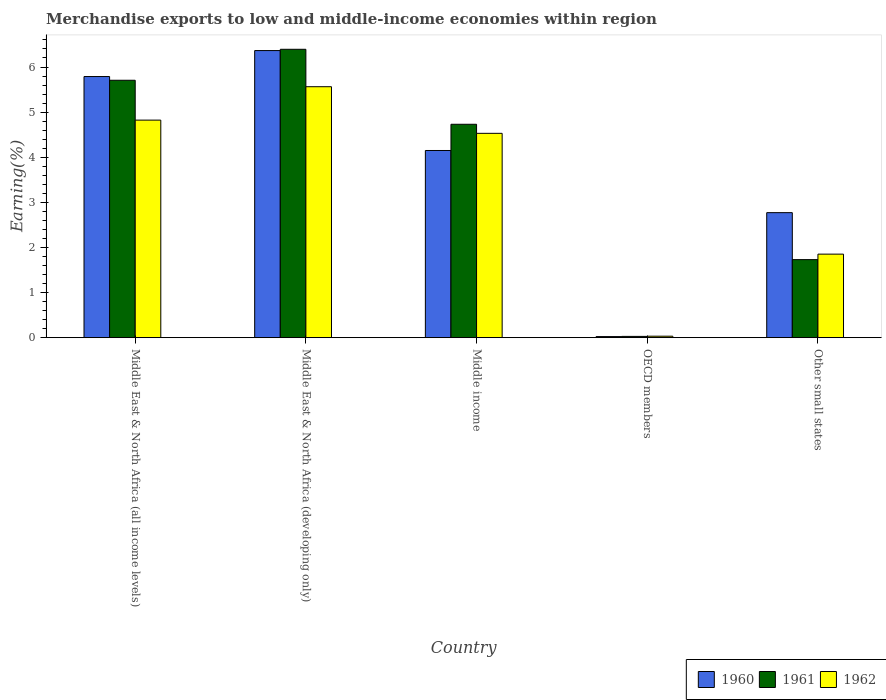Are the number of bars per tick equal to the number of legend labels?
Your answer should be compact. Yes. Are the number of bars on each tick of the X-axis equal?
Your response must be concise. Yes. How many bars are there on the 5th tick from the right?
Keep it short and to the point. 3. In how many cases, is the number of bars for a given country not equal to the number of legend labels?
Offer a terse response. 0. What is the percentage of amount earned from merchandise exports in 1962 in Other small states?
Provide a short and direct response. 1.85. Across all countries, what is the maximum percentage of amount earned from merchandise exports in 1961?
Provide a short and direct response. 6.39. Across all countries, what is the minimum percentage of amount earned from merchandise exports in 1962?
Provide a short and direct response. 0.03. In which country was the percentage of amount earned from merchandise exports in 1962 maximum?
Offer a terse response. Middle East & North Africa (developing only). What is the total percentage of amount earned from merchandise exports in 1961 in the graph?
Your response must be concise. 18.59. What is the difference between the percentage of amount earned from merchandise exports in 1961 in Middle East & North Africa (developing only) and that in Other small states?
Ensure brevity in your answer.  4.66. What is the difference between the percentage of amount earned from merchandise exports in 1961 in Middle income and the percentage of amount earned from merchandise exports in 1962 in Other small states?
Offer a very short reply. 2.88. What is the average percentage of amount earned from merchandise exports in 1962 per country?
Ensure brevity in your answer.  3.36. What is the difference between the percentage of amount earned from merchandise exports of/in 1961 and percentage of amount earned from merchandise exports of/in 1962 in Other small states?
Offer a terse response. -0.12. In how many countries, is the percentage of amount earned from merchandise exports in 1961 greater than 0.8 %?
Provide a short and direct response. 4. What is the ratio of the percentage of amount earned from merchandise exports in 1961 in Middle East & North Africa (all income levels) to that in Middle income?
Make the answer very short. 1.21. What is the difference between the highest and the second highest percentage of amount earned from merchandise exports in 1962?
Offer a very short reply. -0.29. What is the difference between the highest and the lowest percentage of amount earned from merchandise exports in 1962?
Provide a succinct answer. 5.53. In how many countries, is the percentage of amount earned from merchandise exports in 1960 greater than the average percentage of amount earned from merchandise exports in 1960 taken over all countries?
Give a very brief answer. 3. Is it the case that in every country, the sum of the percentage of amount earned from merchandise exports in 1961 and percentage of amount earned from merchandise exports in 1962 is greater than the percentage of amount earned from merchandise exports in 1960?
Offer a terse response. Yes. How many countries are there in the graph?
Ensure brevity in your answer.  5. What is the difference between two consecutive major ticks on the Y-axis?
Make the answer very short. 1. Are the values on the major ticks of Y-axis written in scientific E-notation?
Give a very brief answer. No. Does the graph contain grids?
Provide a succinct answer. No. How are the legend labels stacked?
Provide a succinct answer. Horizontal. What is the title of the graph?
Your answer should be compact. Merchandise exports to low and middle-income economies within region. Does "1960" appear as one of the legend labels in the graph?
Provide a succinct answer. Yes. What is the label or title of the Y-axis?
Offer a terse response. Earning(%). What is the Earning(%) in 1960 in Middle East & North Africa (all income levels)?
Provide a succinct answer. 5.79. What is the Earning(%) of 1961 in Middle East & North Africa (all income levels)?
Provide a succinct answer. 5.71. What is the Earning(%) of 1962 in Middle East & North Africa (all income levels)?
Your answer should be very brief. 4.82. What is the Earning(%) of 1960 in Middle East & North Africa (developing only)?
Your answer should be very brief. 6.36. What is the Earning(%) of 1961 in Middle East & North Africa (developing only)?
Your response must be concise. 6.39. What is the Earning(%) in 1962 in Middle East & North Africa (developing only)?
Keep it short and to the point. 5.56. What is the Earning(%) in 1960 in Middle income?
Provide a short and direct response. 4.15. What is the Earning(%) in 1961 in Middle income?
Offer a very short reply. 4.73. What is the Earning(%) in 1962 in Middle income?
Your response must be concise. 4.53. What is the Earning(%) of 1960 in OECD members?
Provide a succinct answer. 0.02. What is the Earning(%) of 1961 in OECD members?
Your answer should be compact. 0.03. What is the Earning(%) of 1962 in OECD members?
Provide a short and direct response. 0.03. What is the Earning(%) of 1960 in Other small states?
Provide a short and direct response. 2.77. What is the Earning(%) of 1961 in Other small states?
Offer a terse response. 1.73. What is the Earning(%) in 1962 in Other small states?
Give a very brief answer. 1.85. Across all countries, what is the maximum Earning(%) in 1960?
Your answer should be compact. 6.36. Across all countries, what is the maximum Earning(%) of 1961?
Your answer should be very brief. 6.39. Across all countries, what is the maximum Earning(%) of 1962?
Give a very brief answer. 5.56. Across all countries, what is the minimum Earning(%) in 1960?
Provide a short and direct response. 0.02. Across all countries, what is the minimum Earning(%) in 1961?
Offer a very short reply. 0.03. Across all countries, what is the minimum Earning(%) of 1962?
Make the answer very short. 0.03. What is the total Earning(%) in 1960 in the graph?
Provide a short and direct response. 19.1. What is the total Earning(%) of 1961 in the graph?
Your answer should be compact. 18.59. What is the total Earning(%) of 1962 in the graph?
Offer a terse response. 16.8. What is the difference between the Earning(%) of 1960 in Middle East & North Africa (all income levels) and that in Middle East & North Africa (developing only)?
Your response must be concise. -0.58. What is the difference between the Earning(%) of 1961 in Middle East & North Africa (all income levels) and that in Middle East & North Africa (developing only)?
Your response must be concise. -0.69. What is the difference between the Earning(%) of 1962 in Middle East & North Africa (all income levels) and that in Middle East & North Africa (developing only)?
Your answer should be compact. -0.74. What is the difference between the Earning(%) in 1960 in Middle East & North Africa (all income levels) and that in Middle income?
Your answer should be very brief. 1.64. What is the difference between the Earning(%) in 1961 in Middle East & North Africa (all income levels) and that in Middle income?
Ensure brevity in your answer.  0.98. What is the difference between the Earning(%) in 1962 in Middle East & North Africa (all income levels) and that in Middle income?
Provide a succinct answer. 0.29. What is the difference between the Earning(%) in 1960 in Middle East & North Africa (all income levels) and that in OECD members?
Keep it short and to the point. 5.77. What is the difference between the Earning(%) of 1961 in Middle East & North Africa (all income levels) and that in OECD members?
Offer a terse response. 5.68. What is the difference between the Earning(%) of 1962 in Middle East & North Africa (all income levels) and that in OECD members?
Offer a terse response. 4.79. What is the difference between the Earning(%) of 1960 in Middle East & North Africa (all income levels) and that in Other small states?
Your response must be concise. 3.02. What is the difference between the Earning(%) in 1961 in Middle East & North Africa (all income levels) and that in Other small states?
Your answer should be compact. 3.98. What is the difference between the Earning(%) in 1962 in Middle East & North Africa (all income levels) and that in Other small states?
Give a very brief answer. 2.97. What is the difference between the Earning(%) of 1960 in Middle East & North Africa (developing only) and that in Middle income?
Ensure brevity in your answer.  2.22. What is the difference between the Earning(%) in 1961 in Middle East & North Africa (developing only) and that in Middle income?
Your answer should be compact. 1.66. What is the difference between the Earning(%) of 1962 in Middle East & North Africa (developing only) and that in Middle income?
Keep it short and to the point. 1.03. What is the difference between the Earning(%) of 1960 in Middle East & North Africa (developing only) and that in OECD members?
Your answer should be very brief. 6.34. What is the difference between the Earning(%) of 1961 in Middle East & North Africa (developing only) and that in OECD members?
Your response must be concise. 6.37. What is the difference between the Earning(%) of 1962 in Middle East & North Africa (developing only) and that in OECD members?
Offer a very short reply. 5.53. What is the difference between the Earning(%) of 1960 in Middle East & North Africa (developing only) and that in Other small states?
Offer a very short reply. 3.59. What is the difference between the Earning(%) in 1961 in Middle East & North Africa (developing only) and that in Other small states?
Keep it short and to the point. 4.66. What is the difference between the Earning(%) in 1962 in Middle East & North Africa (developing only) and that in Other small states?
Your response must be concise. 3.71. What is the difference between the Earning(%) in 1960 in Middle income and that in OECD members?
Your answer should be compact. 4.13. What is the difference between the Earning(%) of 1961 in Middle income and that in OECD members?
Provide a short and direct response. 4.7. What is the difference between the Earning(%) of 1962 in Middle income and that in OECD members?
Give a very brief answer. 4.5. What is the difference between the Earning(%) of 1960 in Middle income and that in Other small states?
Keep it short and to the point. 1.38. What is the difference between the Earning(%) in 1961 in Middle income and that in Other small states?
Your answer should be compact. 3. What is the difference between the Earning(%) in 1962 in Middle income and that in Other small states?
Offer a terse response. 2.68. What is the difference between the Earning(%) in 1960 in OECD members and that in Other small states?
Provide a succinct answer. -2.75. What is the difference between the Earning(%) in 1961 in OECD members and that in Other small states?
Make the answer very short. -1.7. What is the difference between the Earning(%) in 1962 in OECD members and that in Other small states?
Give a very brief answer. -1.82. What is the difference between the Earning(%) in 1960 in Middle East & North Africa (all income levels) and the Earning(%) in 1961 in Middle East & North Africa (developing only)?
Ensure brevity in your answer.  -0.6. What is the difference between the Earning(%) in 1960 in Middle East & North Africa (all income levels) and the Earning(%) in 1962 in Middle East & North Africa (developing only)?
Your response must be concise. 0.23. What is the difference between the Earning(%) in 1961 in Middle East & North Africa (all income levels) and the Earning(%) in 1962 in Middle East & North Africa (developing only)?
Give a very brief answer. 0.14. What is the difference between the Earning(%) in 1960 in Middle East & North Africa (all income levels) and the Earning(%) in 1961 in Middle income?
Offer a terse response. 1.06. What is the difference between the Earning(%) in 1960 in Middle East & North Africa (all income levels) and the Earning(%) in 1962 in Middle income?
Offer a terse response. 1.26. What is the difference between the Earning(%) in 1961 in Middle East & North Africa (all income levels) and the Earning(%) in 1962 in Middle income?
Your answer should be very brief. 1.18. What is the difference between the Earning(%) in 1960 in Middle East & North Africa (all income levels) and the Earning(%) in 1961 in OECD members?
Your answer should be compact. 5.76. What is the difference between the Earning(%) of 1960 in Middle East & North Africa (all income levels) and the Earning(%) of 1962 in OECD members?
Offer a very short reply. 5.76. What is the difference between the Earning(%) of 1961 in Middle East & North Africa (all income levels) and the Earning(%) of 1962 in OECD members?
Your response must be concise. 5.67. What is the difference between the Earning(%) of 1960 in Middle East & North Africa (all income levels) and the Earning(%) of 1961 in Other small states?
Ensure brevity in your answer.  4.06. What is the difference between the Earning(%) in 1960 in Middle East & North Africa (all income levels) and the Earning(%) in 1962 in Other small states?
Provide a short and direct response. 3.94. What is the difference between the Earning(%) of 1961 in Middle East & North Africa (all income levels) and the Earning(%) of 1962 in Other small states?
Provide a succinct answer. 3.85. What is the difference between the Earning(%) of 1960 in Middle East & North Africa (developing only) and the Earning(%) of 1961 in Middle income?
Make the answer very short. 1.63. What is the difference between the Earning(%) of 1960 in Middle East & North Africa (developing only) and the Earning(%) of 1962 in Middle income?
Provide a short and direct response. 1.83. What is the difference between the Earning(%) in 1961 in Middle East & North Africa (developing only) and the Earning(%) in 1962 in Middle income?
Your response must be concise. 1.86. What is the difference between the Earning(%) of 1960 in Middle East & North Africa (developing only) and the Earning(%) of 1961 in OECD members?
Your response must be concise. 6.34. What is the difference between the Earning(%) of 1960 in Middle East & North Africa (developing only) and the Earning(%) of 1962 in OECD members?
Ensure brevity in your answer.  6.33. What is the difference between the Earning(%) of 1961 in Middle East & North Africa (developing only) and the Earning(%) of 1962 in OECD members?
Your response must be concise. 6.36. What is the difference between the Earning(%) in 1960 in Middle East & North Africa (developing only) and the Earning(%) in 1961 in Other small states?
Provide a succinct answer. 4.63. What is the difference between the Earning(%) in 1960 in Middle East & North Africa (developing only) and the Earning(%) in 1962 in Other small states?
Your answer should be very brief. 4.51. What is the difference between the Earning(%) of 1961 in Middle East & North Africa (developing only) and the Earning(%) of 1962 in Other small states?
Make the answer very short. 4.54. What is the difference between the Earning(%) in 1960 in Middle income and the Earning(%) in 1961 in OECD members?
Your answer should be compact. 4.12. What is the difference between the Earning(%) in 1960 in Middle income and the Earning(%) in 1962 in OECD members?
Your answer should be compact. 4.12. What is the difference between the Earning(%) in 1961 in Middle income and the Earning(%) in 1962 in OECD members?
Provide a succinct answer. 4.7. What is the difference between the Earning(%) in 1960 in Middle income and the Earning(%) in 1961 in Other small states?
Give a very brief answer. 2.42. What is the difference between the Earning(%) in 1960 in Middle income and the Earning(%) in 1962 in Other small states?
Make the answer very short. 2.3. What is the difference between the Earning(%) in 1961 in Middle income and the Earning(%) in 1962 in Other small states?
Ensure brevity in your answer.  2.88. What is the difference between the Earning(%) in 1960 in OECD members and the Earning(%) in 1961 in Other small states?
Offer a terse response. -1.71. What is the difference between the Earning(%) of 1960 in OECD members and the Earning(%) of 1962 in Other small states?
Keep it short and to the point. -1.83. What is the difference between the Earning(%) of 1961 in OECD members and the Earning(%) of 1962 in Other small states?
Provide a short and direct response. -1.82. What is the average Earning(%) in 1960 per country?
Offer a very short reply. 3.82. What is the average Earning(%) of 1961 per country?
Provide a succinct answer. 3.72. What is the average Earning(%) in 1962 per country?
Your response must be concise. 3.36. What is the difference between the Earning(%) in 1960 and Earning(%) in 1961 in Middle East & North Africa (all income levels)?
Give a very brief answer. 0.08. What is the difference between the Earning(%) in 1960 and Earning(%) in 1962 in Middle East & North Africa (all income levels)?
Make the answer very short. 0.97. What is the difference between the Earning(%) of 1961 and Earning(%) of 1962 in Middle East & North Africa (all income levels)?
Offer a very short reply. 0.88. What is the difference between the Earning(%) in 1960 and Earning(%) in 1961 in Middle East & North Africa (developing only)?
Give a very brief answer. -0.03. What is the difference between the Earning(%) in 1960 and Earning(%) in 1962 in Middle East & North Africa (developing only)?
Provide a short and direct response. 0.8. What is the difference between the Earning(%) in 1961 and Earning(%) in 1962 in Middle East & North Africa (developing only)?
Provide a short and direct response. 0.83. What is the difference between the Earning(%) in 1960 and Earning(%) in 1961 in Middle income?
Provide a succinct answer. -0.58. What is the difference between the Earning(%) of 1960 and Earning(%) of 1962 in Middle income?
Keep it short and to the point. -0.38. What is the difference between the Earning(%) of 1961 and Earning(%) of 1962 in Middle income?
Keep it short and to the point. 0.2. What is the difference between the Earning(%) in 1960 and Earning(%) in 1961 in OECD members?
Keep it short and to the point. -0. What is the difference between the Earning(%) in 1960 and Earning(%) in 1962 in OECD members?
Your answer should be very brief. -0.01. What is the difference between the Earning(%) in 1961 and Earning(%) in 1962 in OECD members?
Ensure brevity in your answer.  -0. What is the difference between the Earning(%) in 1960 and Earning(%) in 1961 in Other small states?
Offer a very short reply. 1.04. What is the difference between the Earning(%) in 1960 and Earning(%) in 1962 in Other small states?
Your response must be concise. 0.92. What is the difference between the Earning(%) of 1961 and Earning(%) of 1962 in Other small states?
Provide a short and direct response. -0.12. What is the ratio of the Earning(%) in 1960 in Middle East & North Africa (all income levels) to that in Middle East & North Africa (developing only)?
Provide a short and direct response. 0.91. What is the ratio of the Earning(%) of 1961 in Middle East & North Africa (all income levels) to that in Middle East & North Africa (developing only)?
Keep it short and to the point. 0.89. What is the ratio of the Earning(%) in 1962 in Middle East & North Africa (all income levels) to that in Middle East & North Africa (developing only)?
Offer a terse response. 0.87. What is the ratio of the Earning(%) of 1960 in Middle East & North Africa (all income levels) to that in Middle income?
Your answer should be compact. 1.4. What is the ratio of the Earning(%) of 1961 in Middle East & North Africa (all income levels) to that in Middle income?
Provide a succinct answer. 1.21. What is the ratio of the Earning(%) in 1962 in Middle East & North Africa (all income levels) to that in Middle income?
Offer a terse response. 1.06. What is the ratio of the Earning(%) of 1960 in Middle East & North Africa (all income levels) to that in OECD members?
Your answer should be compact. 243.52. What is the ratio of the Earning(%) in 1961 in Middle East & North Africa (all income levels) to that in OECD members?
Your response must be concise. 203.96. What is the ratio of the Earning(%) in 1962 in Middle East & North Africa (all income levels) to that in OECD members?
Your response must be concise. 148.83. What is the ratio of the Earning(%) in 1960 in Middle East & North Africa (all income levels) to that in Other small states?
Keep it short and to the point. 2.09. What is the ratio of the Earning(%) in 1961 in Middle East & North Africa (all income levels) to that in Other small states?
Provide a succinct answer. 3.3. What is the ratio of the Earning(%) of 1962 in Middle East & North Africa (all income levels) to that in Other small states?
Make the answer very short. 2.6. What is the ratio of the Earning(%) in 1960 in Middle East & North Africa (developing only) to that in Middle income?
Ensure brevity in your answer.  1.53. What is the ratio of the Earning(%) of 1961 in Middle East & North Africa (developing only) to that in Middle income?
Make the answer very short. 1.35. What is the ratio of the Earning(%) of 1962 in Middle East & North Africa (developing only) to that in Middle income?
Offer a terse response. 1.23. What is the ratio of the Earning(%) in 1960 in Middle East & North Africa (developing only) to that in OECD members?
Give a very brief answer. 267.73. What is the ratio of the Earning(%) of 1961 in Middle East & North Africa (developing only) to that in OECD members?
Keep it short and to the point. 228.49. What is the ratio of the Earning(%) of 1962 in Middle East & North Africa (developing only) to that in OECD members?
Keep it short and to the point. 171.7. What is the ratio of the Earning(%) in 1960 in Middle East & North Africa (developing only) to that in Other small states?
Keep it short and to the point. 2.3. What is the ratio of the Earning(%) of 1961 in Middle East & North Africa (developing only) to that in Other small states?
Your answer should be very brief. 3.7. What is the ratio of the Earning(%) of 1962 in Middle East & North Africa (developing only) to that in Other small states?
Ensure brevity in your answer.  3. What is the ratio of the Earning(%) of 1960 in Middle income to that in OECD members?
Provide a succinct answer. 174.55. What is the ratio of the Earning(%) of 1961 in Middle income to that in OECD members?
Your answer should be very brief. 169.08. What is the ratio of the Earning(%) of 1962 in Middle income to that in OECD members?
Make the answer very short. 139.79. What is the ratio of the Earning(%) in 1960 in Middle income to that in Other small states?
Keep it short and to the point. 1.5. What is the ratio of the Earning(%) in 1961 in Middle income to that in Other small states?
Your response must be concise. 2.73. What is the ratio of the Earning(%) of 1962 in Middle income to that in Other small states?
Offer a terse response. 2.45. What is the ratio of the Earning(%) in 1960 in OECD members to that in Other small states?
Offer a terse response. 0.01. What is the ratio of the Earning(%) in 1961 in OECD members to that in Other small states?
Your answer should be very brief. 0.02. What is the ratio of the Earning(%) in 1962 in OECD members to that in Other small states?
Give a very brief answer. 0.02. What is the difference between the highest and the second highest Earning(%) of 1960?
Offer a terse response. 0.58. What is the difference between the highest and the second highest Earning(%) in 1961?
Ensure brevity in your answer.  0.69. What is the difference between the highest and the second highest Earning(%) in 1962?
Your response must be concise. 0.74. What is the difference between the highest and the lowest Earning(%) in 1960?
Your answer should be very brief. 6.34. What is the difference between the highest and the lowest Earning(%) of 1961?
Your answer should be very brief. 6.37. What is the difference between the highest and the lowest Earning(%) of 1962?
Offer a very short reply. 5.53. 